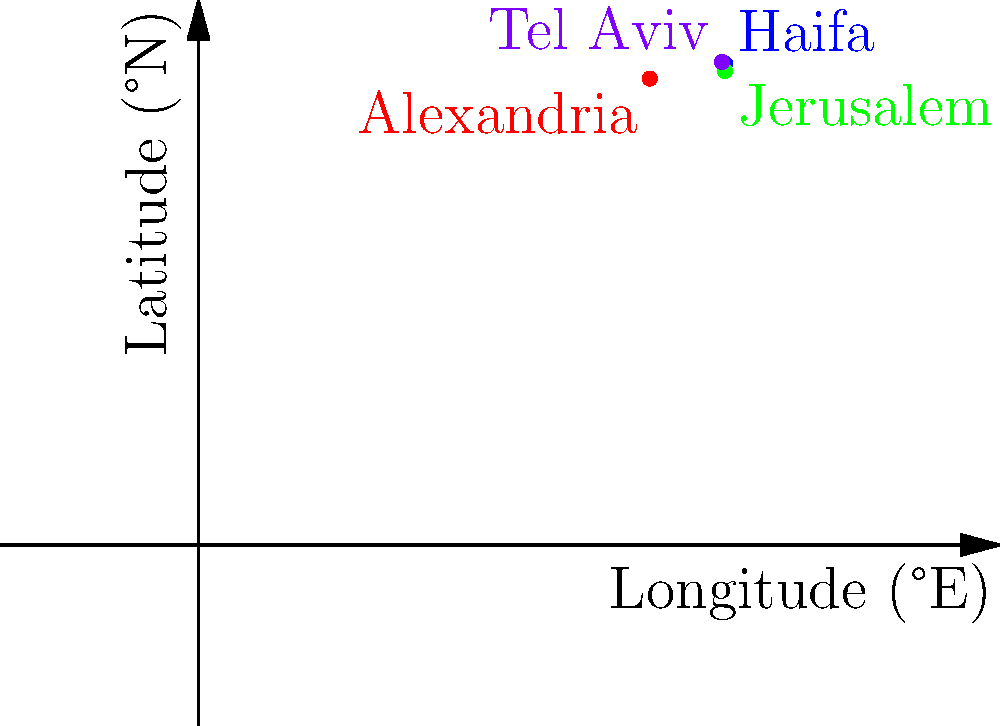On the given coordinate system representing a map of the Eastern Mediterranean, four historical Jewish settlements are plotted. If the coordinates of Jerusalem are $(35°E, 31.5°N)$, which city is represented by the purple dot at approximately $(34.8°E, 32.1°N)$? To solve this question, we need to follow these steps:

1. Identify Jerusalem's location on the map:
   - Jerusalem is marked in green at $(35°E, 31.5°N)$

2. Locate the purple dot:
   - The purple dot is at approximately $(34.8°E, 32.1°N)$

3. Compare the relative positions:
   - The purple dot is slightly west (lower longitude) and north (higher latitude) of Jerusalem

4. Recall historical Jewish settlements in the region:
   - Alexandria (Egypt): southernmost point
   - Jerusalem: central point
   - Haifa: northernmost point
   - Tel Aviv: on the coast, slightly north of Jerusalem

5. Identify the city:
   - Given its coastal location (west of Jerusalem) and being slightly north, the purple dot most likely represents Tel Aviv

This analysis aligns with the historical development of Jewish settlements in the region, particularly the establishment of Tel Aviv as a major Jewish city in the early 20th century.
Answer: Tel Aviv 